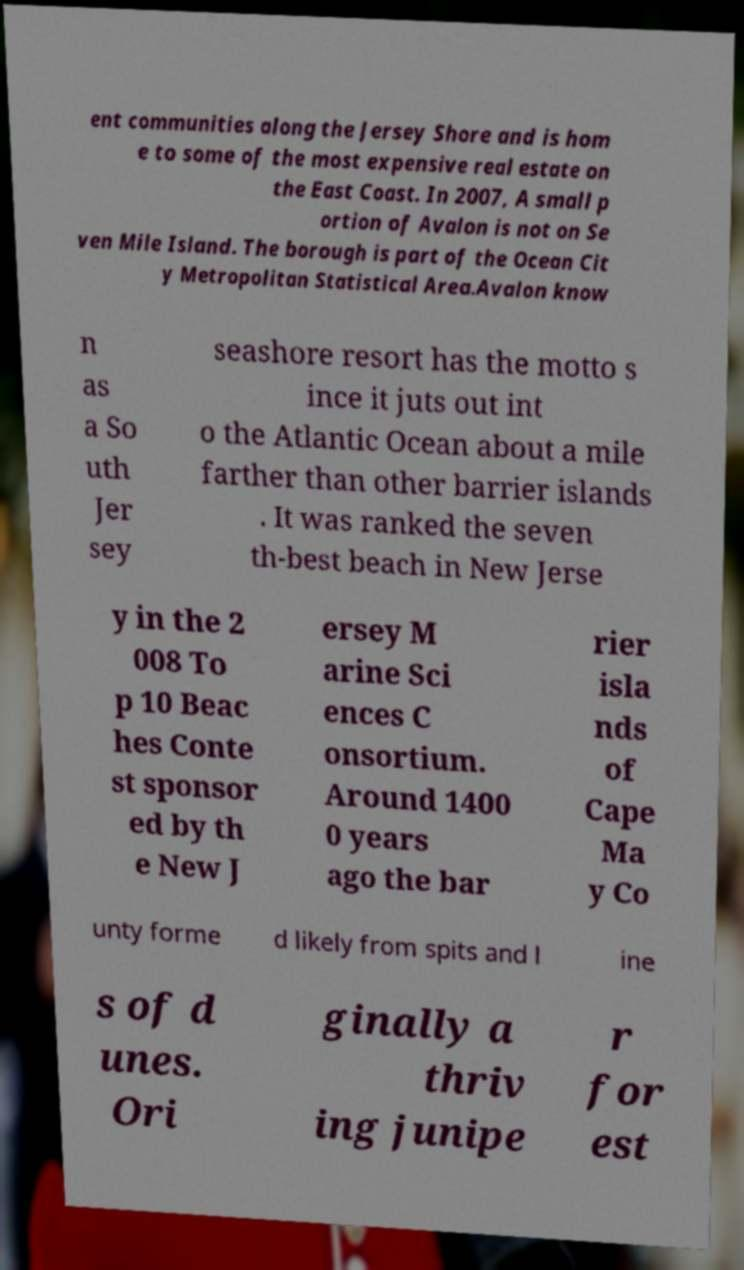Can you read and provide the text displayed in the image?This photo seems to have some interesting text. Can you extract and type it out for me? ent communities along the Jersey Shore and is hom e to some of the most expensive real estate on the East Coast. In 2007, A small p ortion of Avalon is not on Se ven Mile Island. The borough is part of the Ocean Cit y Metropolitan Statistical Area.Avalon know n as a So uth Jer sey seashore resort has the motto s ince it juts out int o the Atlantic Ocean about a mile farther than other barrier islands . It was ranked the seven th-best beach in New Jerse y in the 2 008 To p 10 Beac hes Conte st sponsor ed by th e New J ersey M arine Sci ences C onsortium. Around 1400 0 years ago the bar rier isla nds of Cape Ma y Co unty forme d likely from spits and l ine s of d unes. Ori ginally a thriv ing junipe r for est 